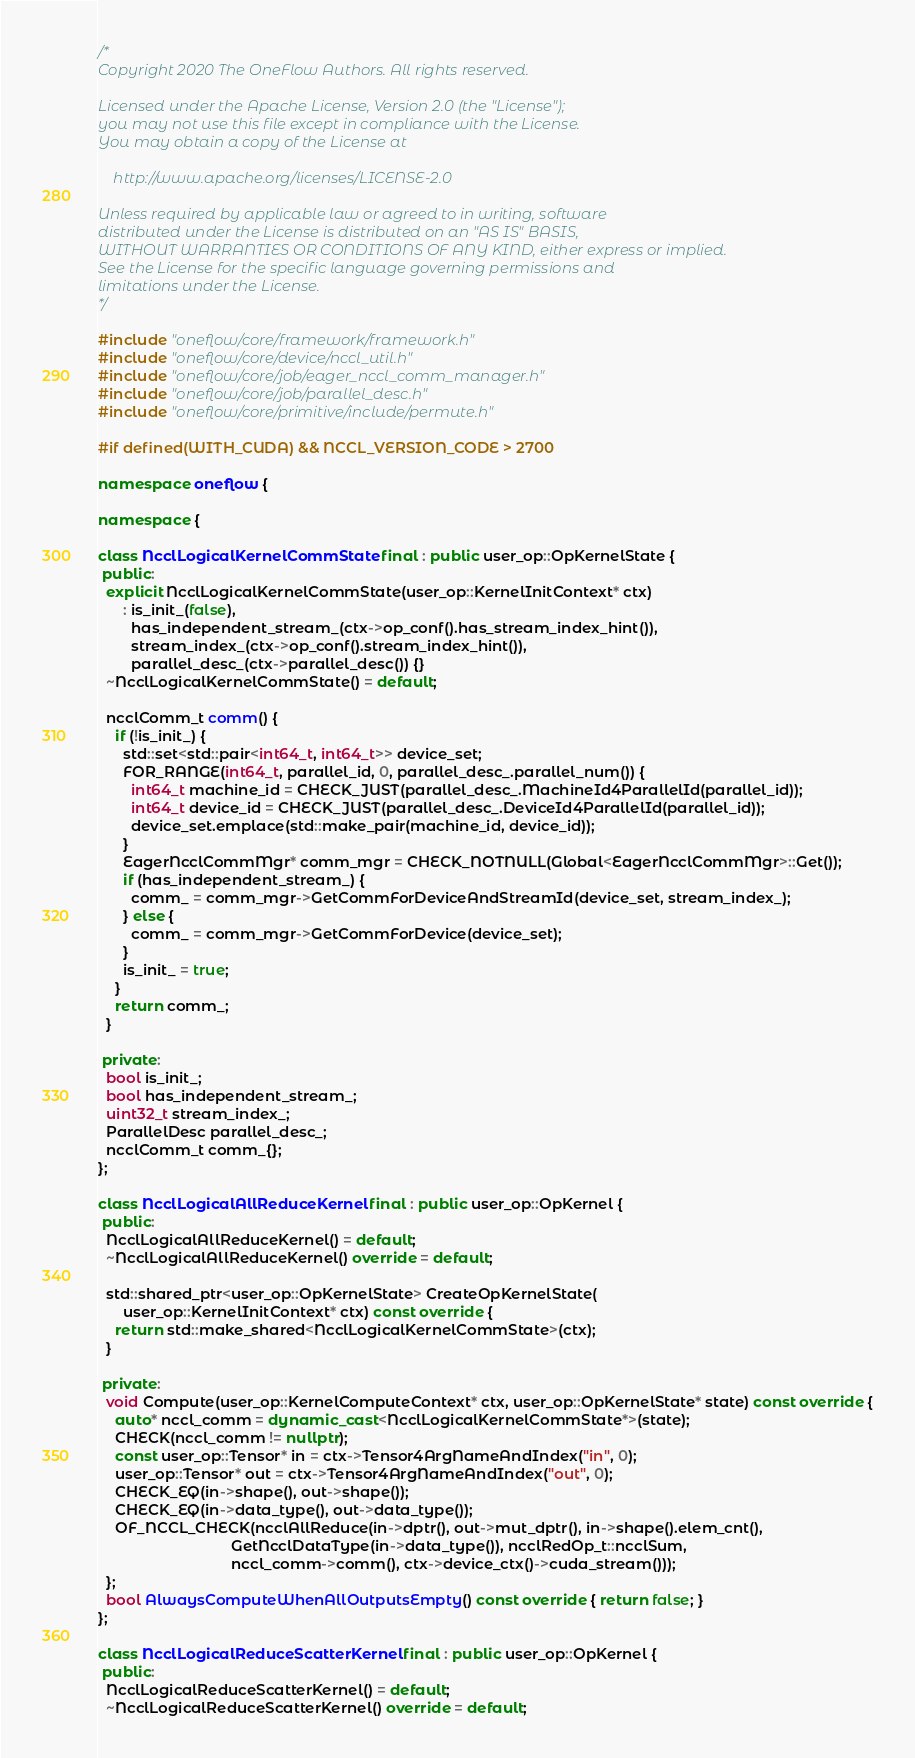Convert code to text. <code><loc_0><loc_0><loc_500><loc_500><_C++_>/*
Copyright 2020 The OneFlow Authors. All rights reserved.

Licensed under the Apache License, Version 2.0 (the "License");
you may not use this file except in compliance with the License.
You may obtain a copy of the License at

    http://www.apache.org/licenses/LICENSE-2.0

Unless required by applicable law or agreed to in writing, software
distributed under the License is distributed on an "AS IS" BASIS,
WITHOUT WARRANTIES OR CONDITIONS OF ANY KIND, either express or implied.
See the License for the specific language governing permissions and
limitations under the License.
*/

#include "oneflow/core/framework/framework.h"
#include "oneflow/core/device/nccl_util.h"
#include "oneflow/core/job/eager_nccl_comm_manager.h"
#include "oneflow/core/job/parallel_desc.h"
#include "oneflow/core/primitive/include/permute.h"

#if defined(WITH_CUDA) && NCCL_VERSION_CODE > 2700

namespace oneflow {

namespace {

class NcclLogicalKernelCommState final : public user_op::OpKernelState {
 public:
  explicit NcclLogicalKernelCommState(user_op::KernelInitContext* ctx)
      : is_init_(false),
        has_independent_stream_(ctx->op_conf().has_stream_index_hint()),
        stream_index_(ctx->op_conf().stream_index_hint()),
        parallel_desc_(ctx->parallel_desc()) {}
  ~NcclLogicalKernelCommState() = default;

  ncclComm_t comm() {
    if (!is_init_) {
      std::set<std::pair<int64_t, int64_t>> device_set;
      FOR_RANGE(int64_t, parallel_id, 0, parallel_desc_.parallel_num()) {
        int64_t machine_id = CHECK_JUST(parallel_desc_.MachineId4ParallelId(parallel_id));
        int64_t device_id = CHECK_JUST(parallel_desc_.DeviceId4ParallelId(parallel_id));
        device_set.emplace(std::make_pair(machine_id, device_id));
      }
      EagerNcclCommMgr* comm_mgr = CHECK_NOTNULL(Global<EagerNcclCommMgr>::Get());
      if (has_independent_stream_) {
        comm_ = comm_mgr->GetCommForDeviceAndStreamId(device_set, stream_index_);
      } else {
        comm_ = comm_mgr->GetCommForDevice(device_set);
      }
      is_init_ = true;
    }
    return comm_;
  }

 private:
  bool is_init_;
  bool has_independent_stream_;
  uint32_t stream_index_;
  ParallelDesc parallel_desc_;
  ncclComm_t comm_{};
};

class NcclLogicalAllReduceKernel final : public user_op::OpKernel {
 public:
  NcclLogicalAllReduceKernel() = default;
  ~NcclLogicalAllReduceKernel() override = default;

  std::shared_ptr<user_op::OpKernelState> CreateOpKernelState(
      user_op::KernelInitContext* ctx) const override {
    return std::make_shared<NcclLogicalKernelCommState>(ctx);
  }

 private:
  void Compute(user_op::KernelComputeContext* ctx, user_op::OpKernelState* state) const override {
    auto* nccl_comm = dynamic_cast<NcclLogicalKernelCommState*>(state);
    CHECK(nccl_comm != nullptr);
    const user_op::Tensor* in = ctx->Tensor4ArgNameAndIndex("in", 0);
    user_op::Tensor* out = ctx->Tensor4ArgNameAndIndex("out", 0);
    CHECK_EQ(in->shape(), out->shape());
    CHECK_EQ(in->data_type(), out->data_type());
    OF_NCCL_CHECK(ncclAllReduce(in->dptr(), out->mut_dptr(), in->shape().elem_cnt(),
                                GetNcclDataType(in->data_type()), ncclRedOp_t::ncclSum,
                                nccl_comm->comm(), ctx->device_ctx()->cuda_stream()));
  };
  bool AlwaysComputeWhenAllOutputsEmpty() const override { return false; }
};

class NcclLogicalReduceScatterKernel final : public user_op::OpKernel {
 public:
  NcclLogicalReduceScatterKernel() = default;
  ~NcclLogicalReduceScatterKernel() override = default;
</code> 